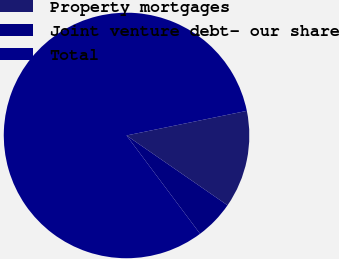<chart> <loc_0><loc_0><loc_500><loc_500><pie_chart><fcel>Property mortgages<fcel>Joint venture debt- our share<fcel>Total<nl><fcel>12.84%<fcel>5.15%<fcel>82.01%<nl></chart> 